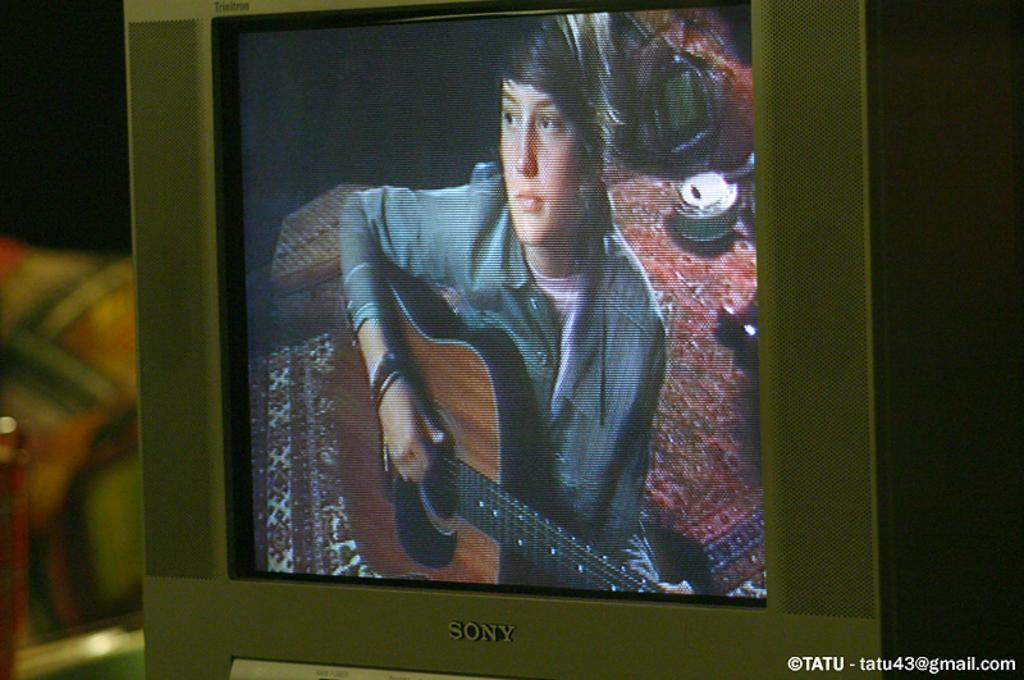Provide a one-sentence caption for the provided image. A sony television shows a person playing guitar on the screen. 